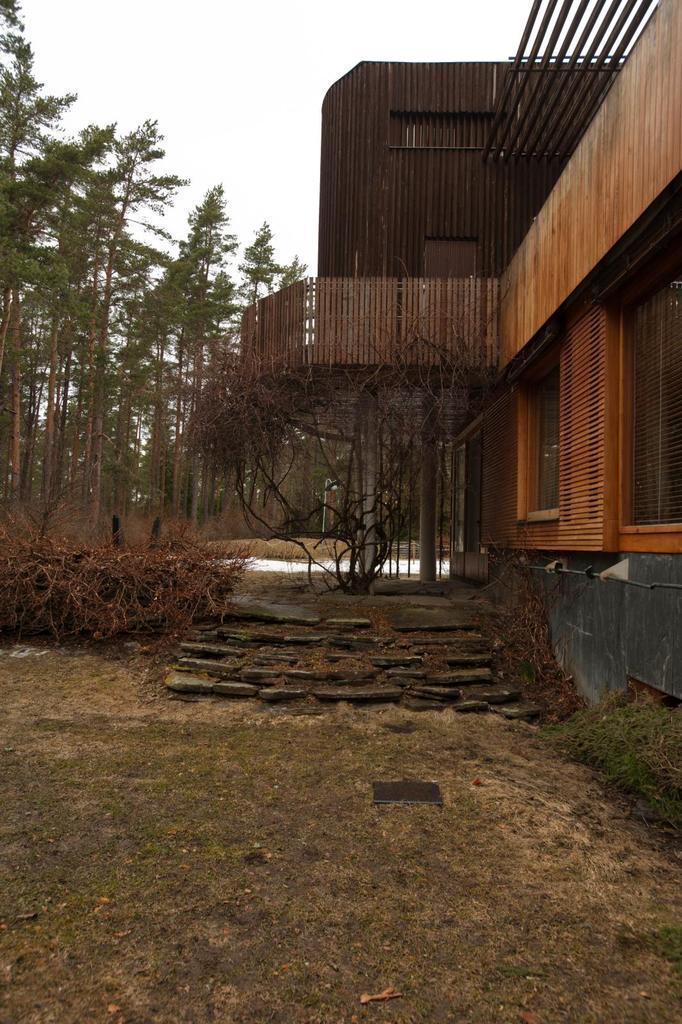Please provide a concise description of this image. In this image on the left side there is one house and in the center there are some stairs and plants, at the bottom there is grass and in the background there are some trees. 